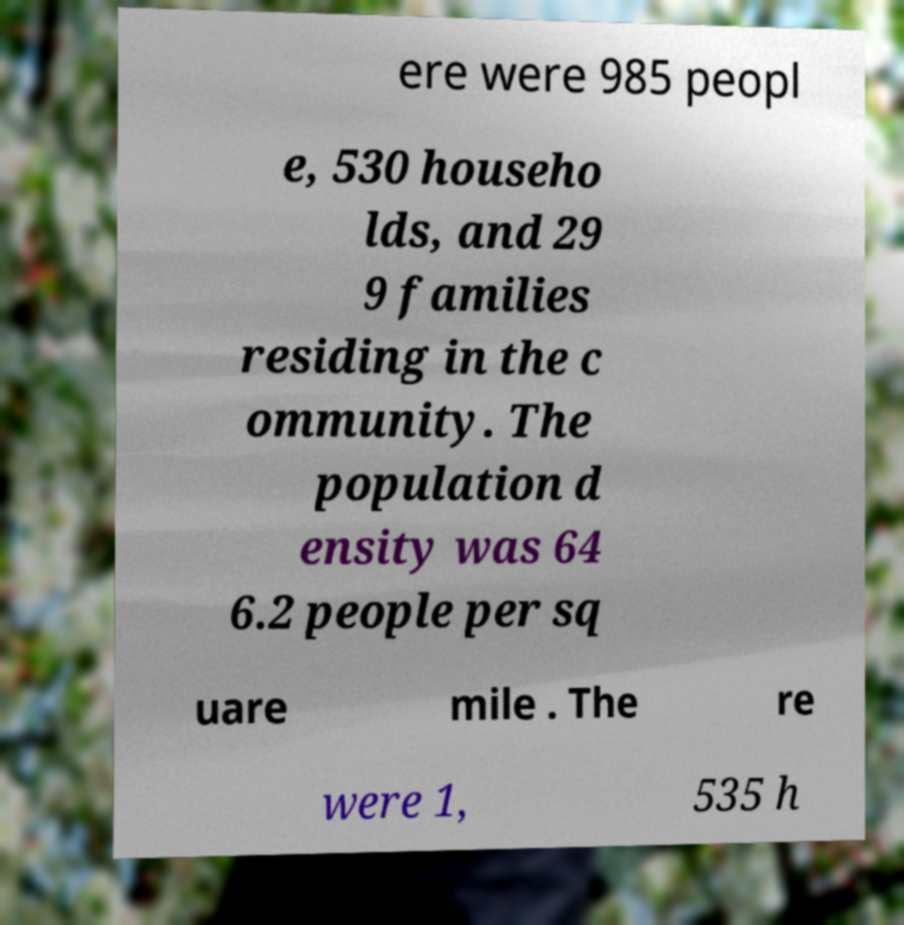Please read and relay the text visible in this image. What does it say? ere were 985 peopl e, 530 househo lds, and 29 9 families residing in the c ommunity. The population d ensity was 64 6.2 people per sq uare mile . The re were 1, 535 h 